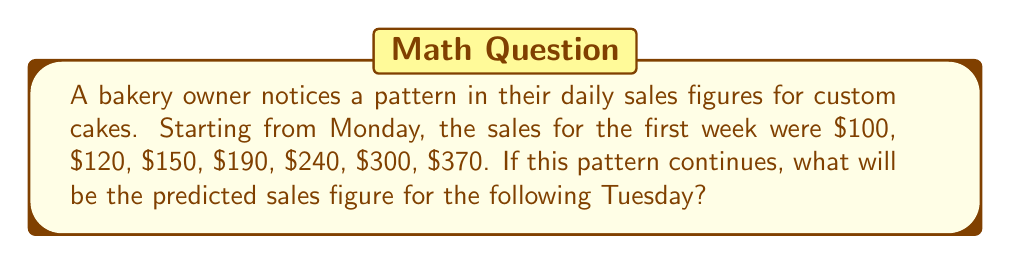Help me with this question. Let's analyze the pattern step-by-step:

1) First, let's calculate the differences between consecutive days:

   $120 - 100 = 20$
   $150 - 120 = 30$
   $190 - 150 = 40$
   $240 - 190 = 50$
   $300 - 240 = 60$
   $370 - 300 = 70$

2) We can see that the difference is increasing by 10 each day:
   
   $20, 30, 40, 50, 60, 70$

3) This forms an arithmetic sequence with a common difference of 10.

4) To predict the next Tuesday's sales, we need to continue this pattern for two more days:

   Next day (Sunday): $370 + 80 = 450$
   Following day (Monday): $450 + 90 = 540$
   Tuesday (our target): $540 + 100 = 640$

5) We can verify this using the general term formula for arithmetic sequences:
   
   $a_n = a_1 + (n-1)d$

   Where $a_1 = 100$ (first term), $d = 10$ (common difference of the differences), and $n = 9$ (9th day from the start)

   $a_9 = 100 + (9-1)(10) = 100 + 80 = 180$

   The 9th term of the difference sequence is indeed 180, confirming our calculation.

Therefore, the predicted sales figure for the following Tuesday is $640.
Answer: $640 